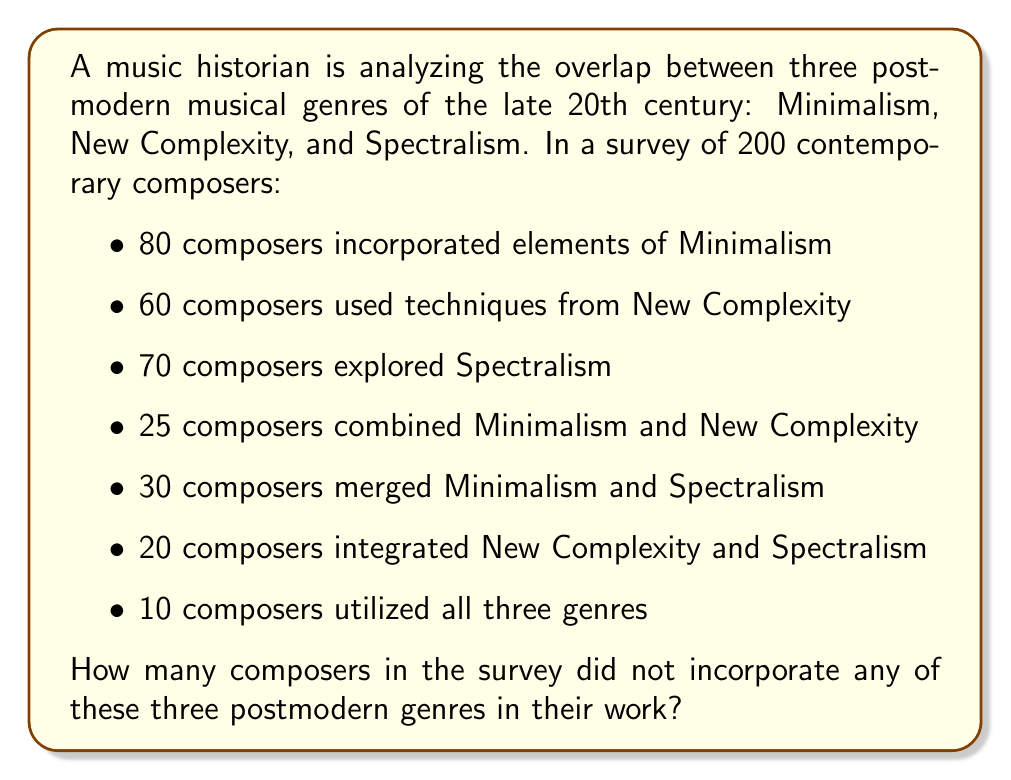Show me your answer to this math problem. To solve this problem, we'll use the principle of inclusion-exclusion for three sets. Let's define our sets:

$M$: composers using Minimalism
$N$: composers using New Complexity
$S$: composers using Spectralism

We're given:
$|M| = 80$, $|N| = 60$, $|S| = 70$
$|M \cap N| = 25$, $|M \cap S| = 30$, $|N \cap S| = 20$
$|M \cap N \cap S| = 10$

The total number of composers using at least one of these genres is:

$$|M \cup N \cup S| = |M| + |N| + |S| - |M \cap N| - |M \cap S| - |N \cap S| + |M \cap N \cap S|$$

Substituting the values:

$$|M \cup N \cup S| = 80 + 60 + 70 - 25 - 30 - 20 + 10 = 145$$

Since there are 200 composers in total, the number of composers not using any of these genres is:

$$200 - 145 = 55$$
Answer: 55 composers 